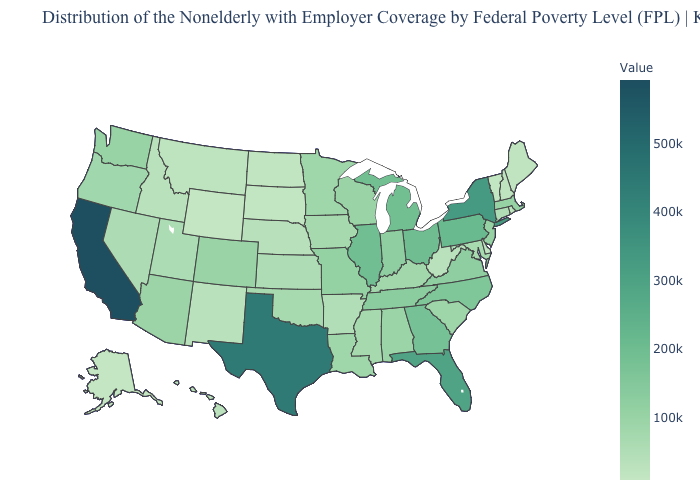Among the states that border North Dakota , which have the highest value?
Quick response, please. Minnesota. Does Vermont have the highest value in the USA?
Write a very short answer. No. Does Nebraska have the highest value in the MidWest?
Short answer required. No. Among the states that border North Dakota , which have the highest value?
Keep it brief. Minnesota. 